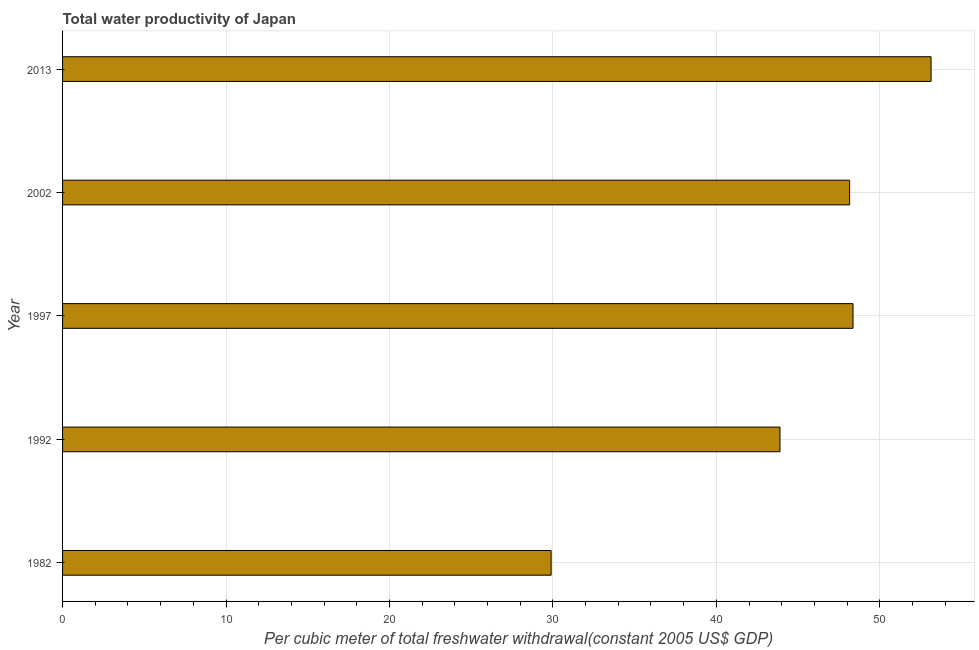Does the graph contain grids?
Keep it short and to the point. Yes. What is the title of the graph?
Offer a terse response. Total water productivity of Japan. What is the label or title of the X-axis?
Your answer should be compact. Per cubic meter of total freshwater withdrawal(constant 2005 US$ GDP). What is the total water productivity in 2002?
Your answer should be very brief. 48.16. Across all years, what is the maximum total water productivity?
Provide a short and direct response. 53.14. Across all years, what is the minimum total water productivity?
Your response must be concise. 29.89. In which year was the total water productivity maximum?
Provide a short and direct response. 2013. What is the sum of the total water productivity?
Offer a terse response. 223.44. What is the difference between the total water productivity in 1982 and 2013?
Give a very brief answer. -23.25. What is the average total water productivity per year?
Provide a succinct answer. 44.69. What is the median total water productivity?
Keep it short and to the point. 48.16. In how many years, is the total water productivity greater than 24 US$?
Offer a terse response. 5. Do a majority of the years between 2002 and 1992 (inclusive) have total water productivity greater than 26 US$?
Your response must be concise. Yes. What is the ratio of the total water productivity in 1982 to that in 1992?
Keep it short and to the point. 0.68. Is the total water productivity in 1992 less than that in 2013?
Give a very brief answer. Yes. Is the difference between the total water productivity in 1982 and 2013 greater than the difference between any two years?
Your response must be concise. Yes. What is the difference between the highest and the second highest total water productivity?
Your answer should be very brief. 4.78. Is the sum of the total water productivity in 1992 and 1997 greater than the maximum total water productivity across all years?
Your answer should be compact. Yes. What is the difference between the highest and the lowest total water productivity?
Provide a succinct answer. 23.25. In how many years, is the total water productivity greater than the average total water productivity taken over all years?
Ensure brevity in your answer.  3. How many years are there in the graph?
Make the answer very short. 5. What is the Per cubic meter of total freshwater withdrawal(constant 2005 US$ GDP) of 1982?
Your answer should be very brief. 29.89. What is the Per cubic meter of total freshwater withdrawal(constant 2005 US$ GDP) in 1992?
Provide a short and direct response. 43.89. What is the Per cubic meter of total freshwater withdrawal(constant 2005 US$ GDP) in 1997?
Give a very brief answer. 48.36. What is the Per cubic meter of total freshwater withdrawal(constant 2005 US$ GDP) in 2002?
Offer a terse response. 48.16. What is the Per cubic meter of total freshwater withdrawal(constant 2005 US$ GDP) of 2013?
Offer a very short reply. 53.14. What is the difference between the Per cubic meter of total freshwater withdrawal(constant 2005 US$ GDP) in 1982 and 1992?
Make the answer very short. -14. What is the difference between the Per cubic meter of total freshwater withdrawal(constant 2005 US$ GDP) in 1982 and 1997?
Offer a very short reply. -18.47. What is the difference between the Per cubic meter of total freshwater withdrawal(constant 2005 US$ GDP) in 1982 and 2002?
Make the answer very short. -18.26. What is the difference between the Per cubic meter of total freshwater withdrawal(constant 2005 US$ GDP) in 1982 and 2013?
Your answer should be compact. -23.25. What is the difference between the Per cubic meter of total freshwater withdrawal(constant 2005 US$ GDP) in 1992 and 1997?
Provide a short and direct response. -4.47. What is the difference between the Per cubic meter of total freshwater withdrawal(constant 2005 US$ GDP) in 1992 and 2002?
Provide a succinct answer. -4.26. What is the difference between the Per cubic meter of total freshwater withdrawal(constant 2005 US$ GDP) in 1992 and 2013?
Offer a very short reply. -9.24. What is the difference between the Per cubic meter of total freshwater withdrawal(constant 2005 US$ GDP) in 1997 and 2002?
Make the answer very short. 0.21. What is the difference between the Per cubic meter of total freshwater withdrawal(constant 2005 US$ GDP) in 1997 and 2013?
Your response must be concise. -4.77. What is the difference between the Per cubic meter of total freshwater withdrawal(constant 2005 US$ GDP) in 2002 and 2013?
Your response must be concise. -4.98. What is the ratio of the Per cubic meter of total freshwater withdrawal(constant 2005 US$ GDP) in 1982 to that in 1992?
Your answer should be very brief. 0.68. What is the ratio of the Per cubic meter of total freshwater withdrawal(constant 2005 US$ GDP) in 1982 to that in 1997?
Your answer should be very brief. 0.62. What is the ratio of the Per cubic meter of total freshwater withdrawal(constant 2005 US$ GDP) in 1982 to that in 2002?
Make the answer very short. 0.62. What is the ratio of the Per cubic meter of total freshwater withdrawal(constant 2005 US$ GDP) in 1982 to that in 2013?
Ensure brevity in your answer.  0.56. What is the ratio of the Per cubic meter of total freshwater withdrawal(constant 2005 US$ GDP) in 1992 to that in 1997?
Make the answer very short. 0.91. What is the ratio of the Per cubic meter of total freshwater withdrawal(constant 2005 US$ GDP) in 1992 to that in 2002?
Offer a very short reply. 0.91. What is the ratio of the Per cubic meter of total freshwater withdrawal(constant 2005 US$ GDP) in 1992 to that in 2013?
Give a very brief answer. 0.83. What is the ratio of the Per cubic meter of total freshwater withdrawal(constant 2005 US$ GDP) in 1997 to that in 2002?
Keep it short and to the point. 1. What is the ratio of the Per cubic meter of total freshwater withdrawal(constant 2005 US$ GDP) in 1997 to that in 2013?
Give a very brief answer. 0.91. What is the ratio of the Per cubic meter of total freshwater withdrawal(constant 2005 US$ GDP) in 2002 to that in 2013?
Your answer should be compact. 0.91. 